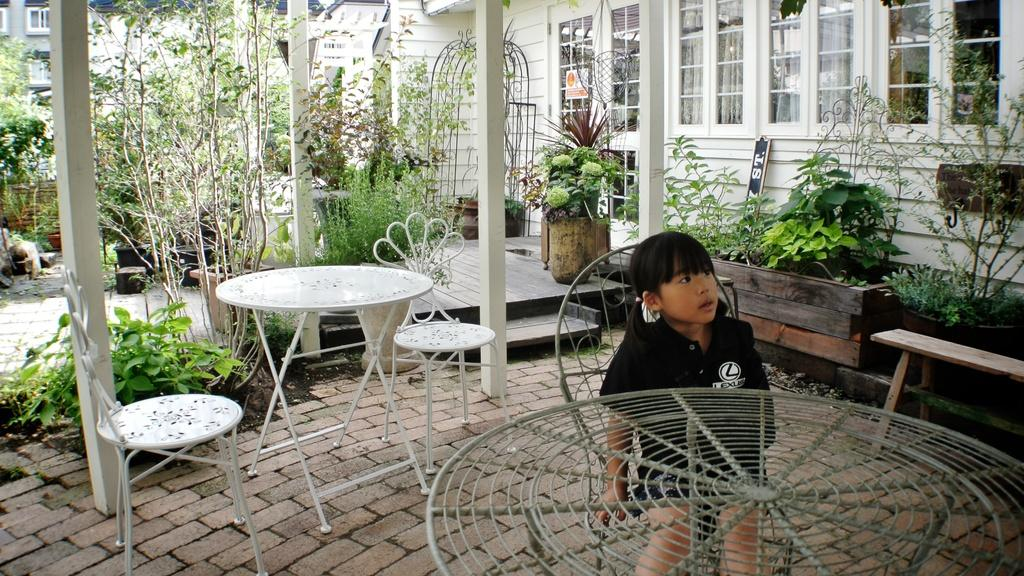What is the girl in the image doing? The girl is sitting on a chair in the image. Can you describe the setting in the background of the image? In the background of the image, there are multiple chairs, tables, plants, and buildings. How many chairs are visible in the image? There is one chair with the girl sitting on it, and multiple chairs in the background. What type of cow can be seen walking in the background of the image? There is no cow present in the image; the background features chairs, tables, plants, and buildings. 